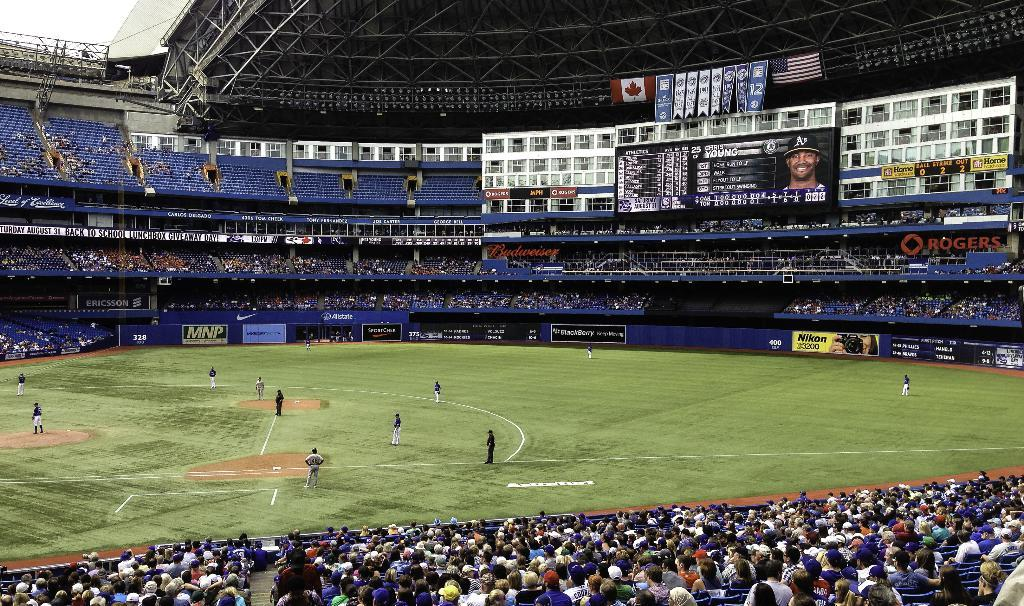What is happening in the image involving the group of people? Some people are playing a game in the ground. What can be seen in the background of the image? There are metal rods, chairs, hoardings, and a screen in the background of the image. How many people are involved in the game? The number of people involved in the game cannot be determined from the image alone. What advertisement is being displayed on the screen in the image? There is no screen present in the image, so no advertisement can be observed. 